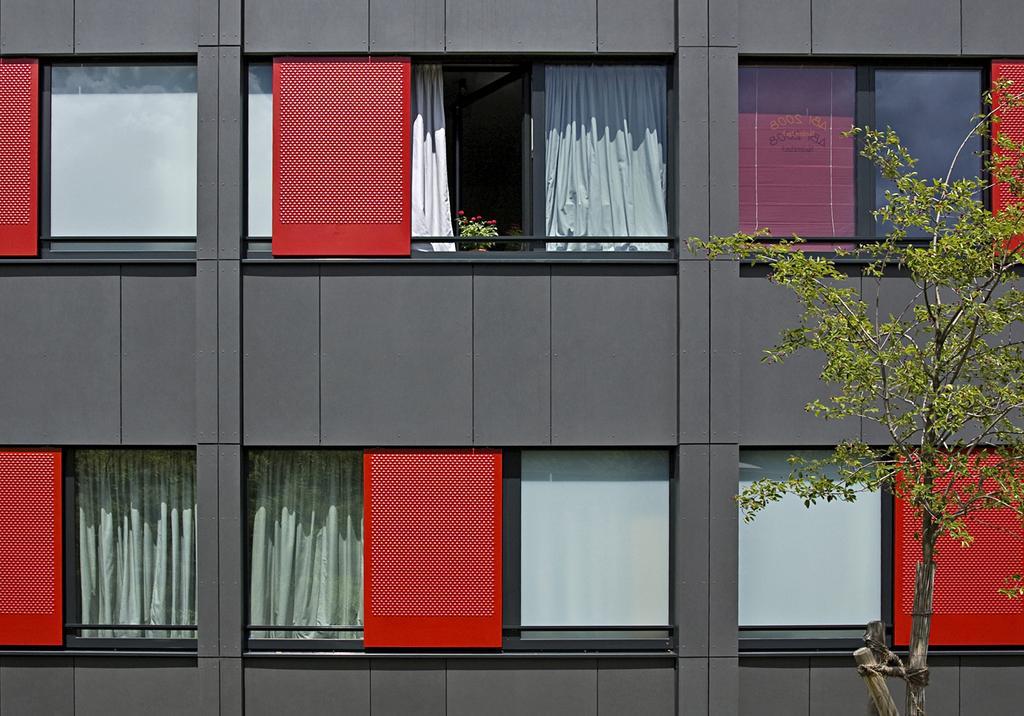How would you summarize this image in a sentence or two? To this building there are glass windows. Through these windows we can see curtains and plant. In-front of this building there is a tree.   